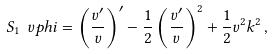Convert formula to latex. <formula><loc_0><loc_0><loc_500><loc_500>S _ { 1 } \ v p h i = \left ( \frac { v ^ { \prime } } { v } \right ) ^ { \prime } - \frac { 1 } { 2 } \left ( \frac { v ^ { \prime } } { v } \right ) ^ { 2 } + \frac { 1 } { 2 } v ^ { 2 } k ^ { 2 } \, ,</formula> 